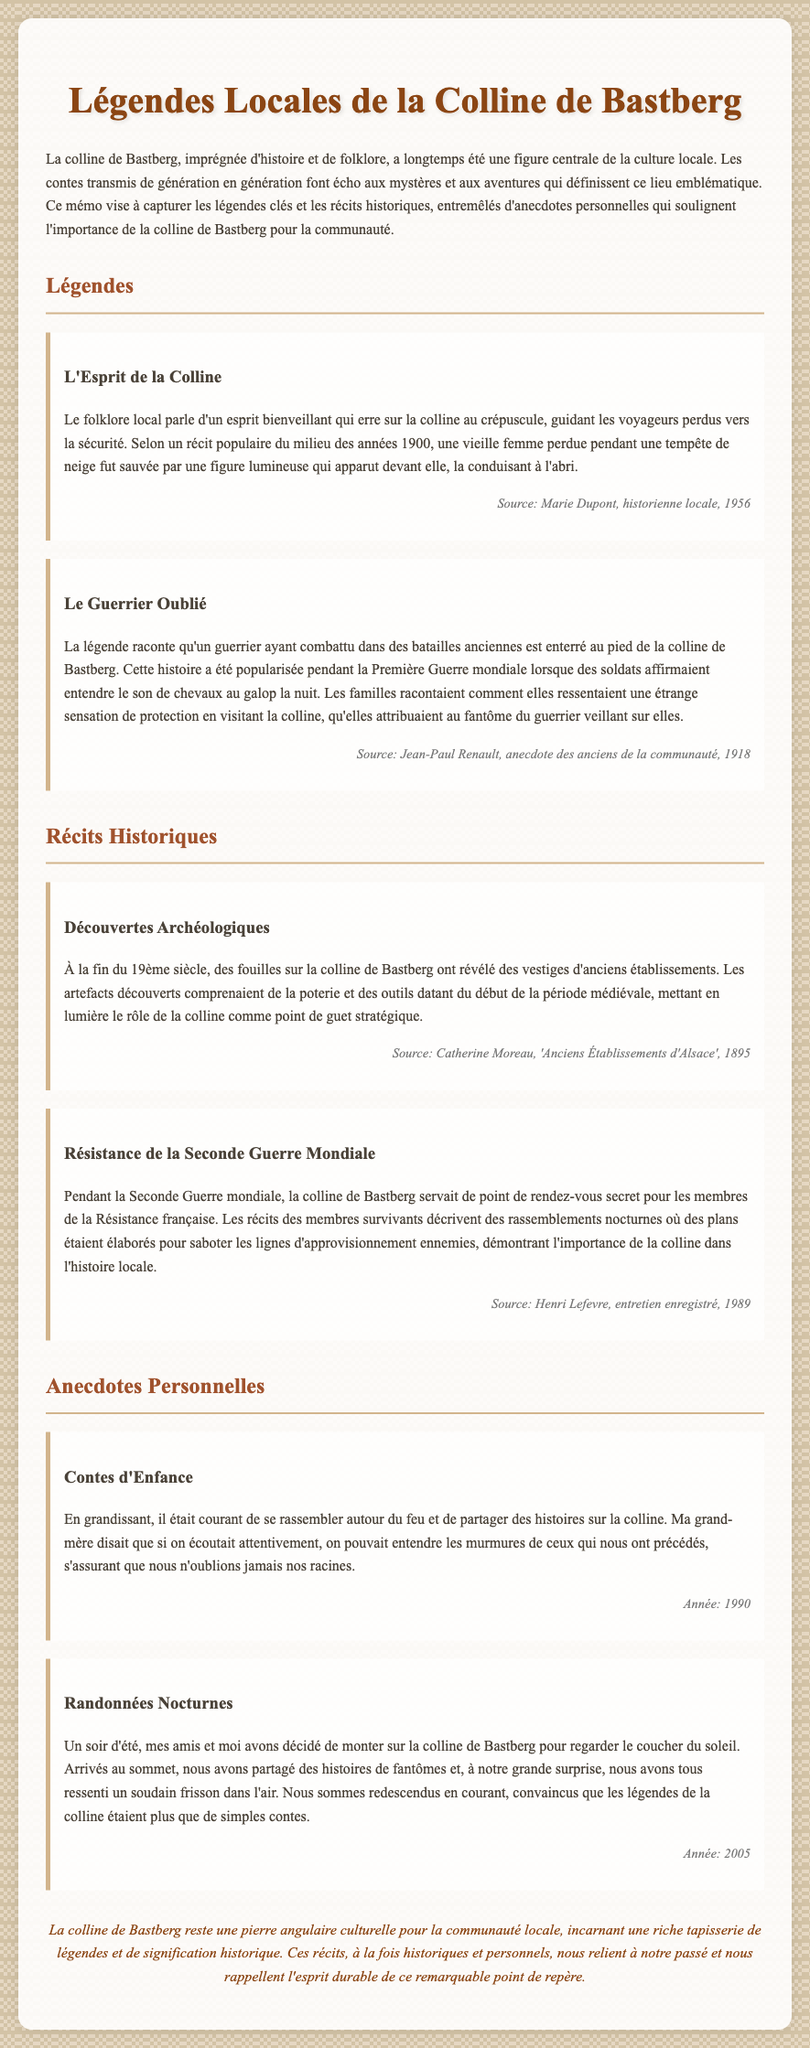Quelle est la première légende mentionnée ? La première légende mentionnée dans le document est « L'Esprit de la Colline », décrivant un esprit bienveillant.
Answer: L'Esprit de la Colline Qui a écrit sur les découvertes archéologiques ? Les découvertes archéologiques sont décrites par Catherine Moreau dans son ouvrage 'Anciens Établissements d'Alsace'.
Answer: Catherine Moreau Quand se sont produites les fouilles archéologiques ? Les fouilles archéologiques sur la colline de Bastberg ont été effectuées à la fin du 19ème siècle.
Answer: Fin du 19ème siècle Quel est le sujet de l'anecdote personnelle concernant l'été ? L'anecdote personnelle parle d'une randonnée nocturne sur la colline de Bastberg et de la sensation de frisson ressentie.
Answer: Randonnées Nocturnes Quelle année est associée à l'anecdote sur les contes d'enfance ? L'anecdote sur les contes d'enfance est associés à l'année 1990.
Answer: 1990 Qui a rapporté les récits d'une protection ressentie lors des visites ? Jean-Paul Renault a rapporté que les familles ressentaient une protection en visitant la colline.
Answer: Jean-Paul Renault Quel type de lieu la colline représentait pendant la Seconde Guerre mondiale ? Pendant la Seconde Guerre mondiale, la colline de Bastberg servait de point de rendez-vous secret pour la Résistance française.
Answer: Point de rendez-vous secret Quel est le thème central des légendes de la colline de Bastberg ? Le thème central est l'importance de la colline de Bastberg dans le folklore et l'histoire locale.
Answer: Importance culturelle 